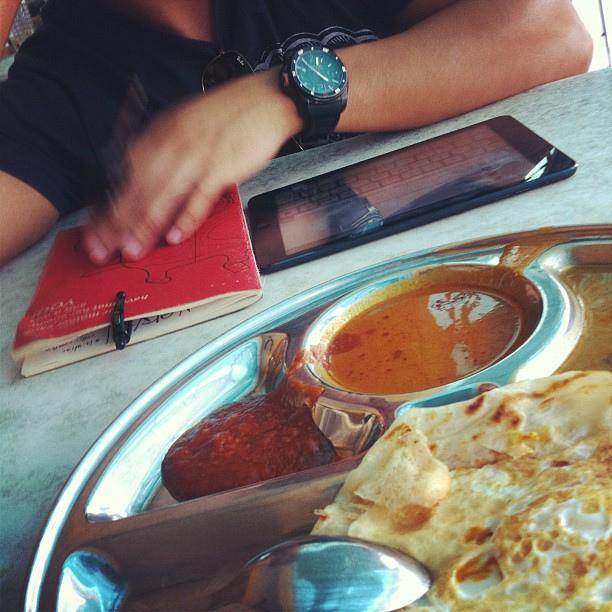What is the silver plate the man is using made of?

Choices:
A) metal
B) plastic
C) paper
D) wood metal 